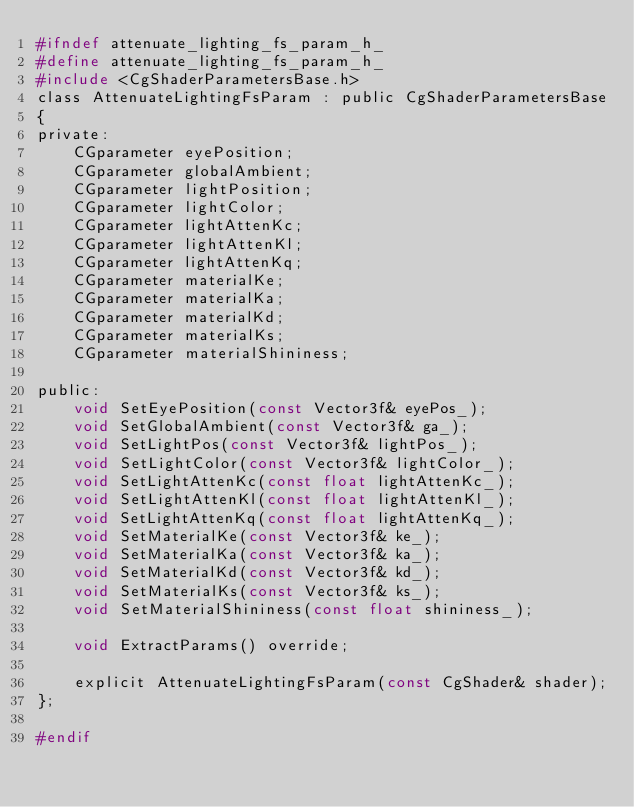Convert code to text. <code><loc_0><loc_0><loc_500><loc_500><_C_>#ifndef attenuate_lighting_fs_param_h_
#define attenuate_lighting_fs_param_h_
#include <CgShaderParametersBase.h>
class AttenuateLightingFsParam : public CgShaderParametersBase
{
private:
    CGparameter eyePosition;
    CGparameter globalAmbient;
    CGparameter lightPosition;
    CGparameter lightColor;
    CGparameter lightAttenKc;
    CGparameter lightAttenKl;
    CGparameter lightAttenKq;
    CGparameter materialKe;
    CGparameter materialKa;
    CGparameter materialKd;
    CGparameter materialKs;
    CGparameter materialShininess;

public:
    void SetEyePosition(const Vector3f& eyePos_);
    void SetGlobalAmbient(const Vector3f& ga_);
    void SetLightPos(const Vector3f& lightPos_);
    void SetLightColor(const Vector3f& lightColor_);
    void SetLightAttenKc(const float lightAttenKc_);
    void SetLightAttenKl(const float lightAttenKl_);
    void SetLightAttenKq(const float lightAttenKq_);
    void SetMaterialKe(const Vector3f& ke_);
    void SetMaterialKa(const Vector3f& ka_);
    void SetMaterialKd(const Vector3f& kd_);
    void SetMaterialKs(const Vector3f& ks_);
    void SetMaterialShininess(const float shininess_);

    void ExtractParams() override;

    explicit AttenuateLightingFsParam(const CgShader& shader);
};

#endif</code> 